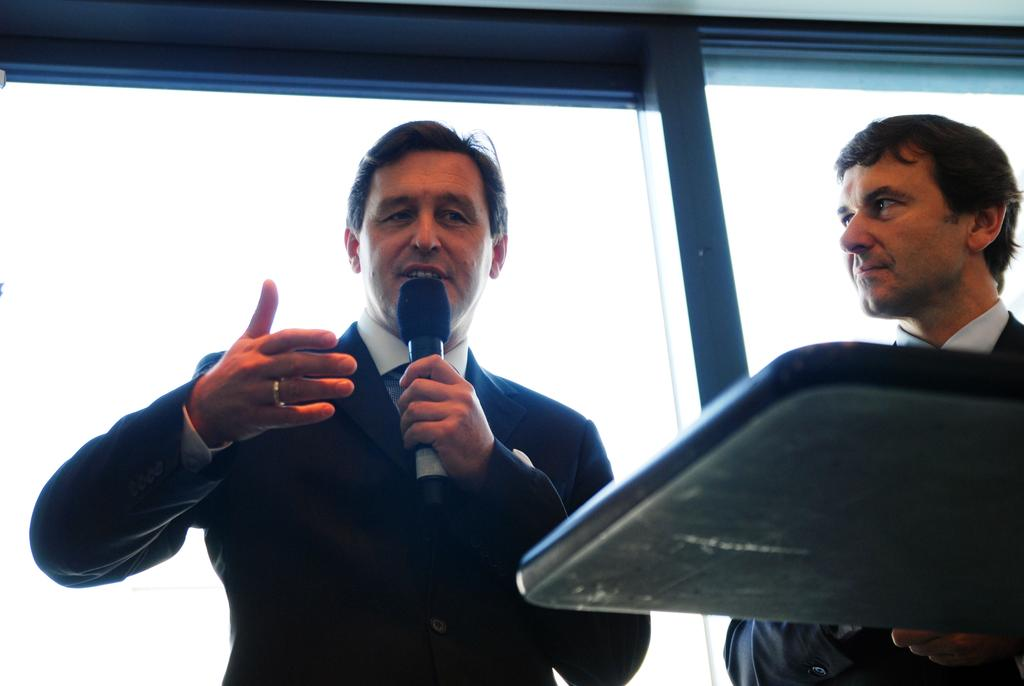How many people are in the image? There are two men in the image. What are the men wearing? Both men are wearing blazers. What is one of the men holding? One man is holding a microphone in his hand. What is the man with the microphone doing? The man with the microphone is talking. What is the other man doing? The other man is looking at the man with the microphone. What can be seen in the background of the image? There is a wall visible in the background of the image. How many babies are crawling on the floor in the image? There are no babies present in the image. What type of bean is being used as a prop in the image? There is no bean present in the image. 